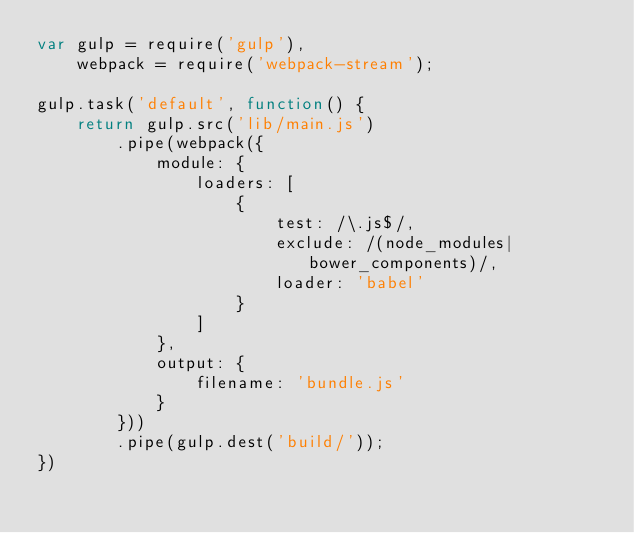Convert code to text. <code><loc_0><loc_0><loc_500><loc_500><_JavaScript_>var gulp = require('gulp'),
    webpack = require('webpack-stream');

gulp.task('default', function() {
    return gulp.src('lib/main.js')
        .pipe(webpack({
            module: {
                loaders: [
                    {
                        test: /\.js$/,
                        exclude: /(node_modules|bower_components)/,
                        loader: 'babel'
                    }
                ]
            },
            output: {
                filename: 'bundle.js'
            }
        }))
        .pipe(gulp.dest('build/'));
})
</code> 